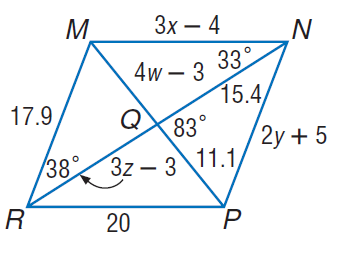Answer the mathemtical geometry problem and directly provide the correct option letter.
Question: Use parallelogram M N P R to find z.
Choices: A: 6.1 B: 11.1 C: 15.3 D: 18.3 A 